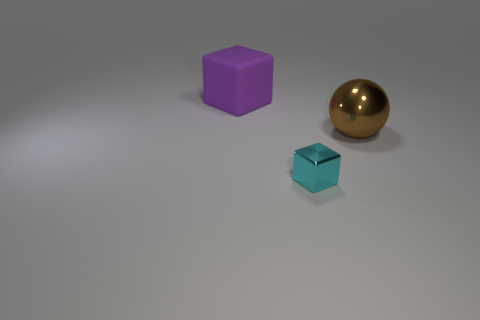Is there any other thing that is the same size as the cyan metal thing?
Give a very brief answer. No. There is a big thing that is on the left side of the small metallic block; is its shape the same as the metal object that is in front of the brown sphere?
Keep it short and to the point. Yes. What shape is the large thing that is left of the cube that is in front of the purple matte thing?
Keep it short and to the point. Cube. Are there any cyan blocks made of the same material as the large sphere?
Ensure brevity in your answer.  Yes. There is a object that is in front of the large metallic ball; what is its material?
Make the answer very short. Metal. What is the material of the tiny cyan block?
Ensure brevity in your answer.  Metal. Is the material of the object left of the cyan cube the same as the brown thing?
Offer a very short reply. No. Are there fewer cyan metal blocks that are in front of the shiny cube than tiny metal balls?
Provide a short and direct response. No. The thing that is the same size as the metallic ball is what color?
Your response must be concise. Purple. How many other purple objects are the same shape as the purple rubber object?
Make the answer very short. 0. 